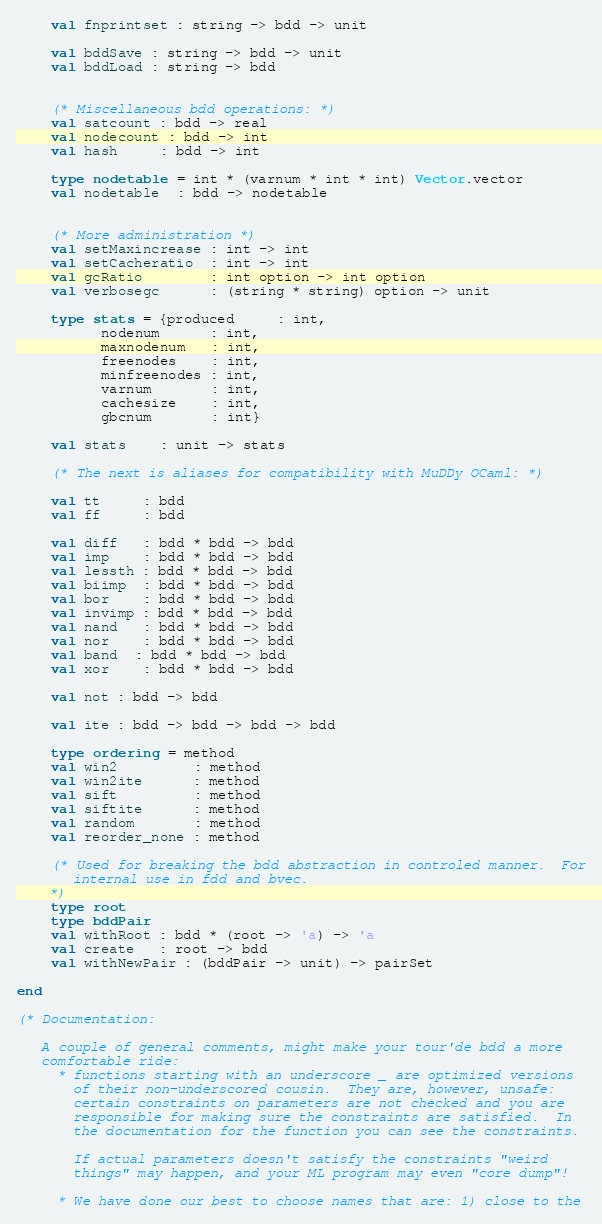Convert code to text. <code><loc_0><loc_0><loc_500><loc_500><_SML_>    val fnprintset : string -> bdd -> unit

    val bddSave : string -> bdd -> unit
    val bddLoad : string -> bdd

 
    (* Miscellaneous bdd operations: *)
    val satcount : bdd -> real
    val nodecount : bdd -> int
    val hash     : bdd -> int
    
    type nodetable = int * (varnum * int * int) Vector.vector
    val nodetable  : bdd -> nodetable 


    (* More administration *)
    val setMaxincrease : int -> int
    val setCacheratio  : int -> int
    val gcRatio        : int option -> int option
    val verbosegc      : (string * string) option -> unit

    type stats = {produced     : int,
		  nodenum      : int,
		  maxnodenum   : int,
		  freenodes    : int,
		  minfreenodes : int,
		  varnum       : int,
		  cachesize    : int,
		  gbcnum       : int}

    val stats    : unit -> stats

    (* The next is aliases for compatibility with MuDDy OCaml: *)

    val tt     : bdd
    val ff     : bdd

    val diff   : bdd * bdd -> bdd
    val imp    : bdd * bdd -> bdd
    val lessth : bdd * bdd -> bdd
    val biimp  : bdd * bdd -> bdd
    val bor    : bdd * bdd -> bdd
    val invimp : bdd * bdd -> bdd
    val nand   : bdd * bdd -> bdd
    val nor    : bdd * bdd -> bdd
    val band  : bdd * bdd -> bdd
    val xor    : bdd * bdd -> bdd

    val not : bdd -> bdd

    val ite : bdd -> bdd -> bdd -> bdd

    type ordering = method
    val win2         : method
    val win2ite      : method
    val sift         : method
    val siftite      : method
    val random       : method
    val reorder_none : method

    (* Used for breaking the bdd abstraction in controled manner.  For
       internal use in fdd and bvec.  
    *)
    type root
    type bddPair
    val withRoot : bdd * (root -> 'a) -> 'a
    val create   : root -> bdd
    val withNewPair : (bddPair -> unit) -> pairSet

end

(* Documentation:

   A couple of general comments, might make your tour'de bdd a more
   comfortable ride:
     * functions starting with an underscore _ are optimized versions
       of their non-underscored cousin.  They are, however, unsafe:
       certain constraints on parameters are not checked and you are
       responsible for making sure the constraints are satisfied.  In
       the documentation for the function you can see the constraints.

       If actual parameters doesn't satisfy the constraints "weird
       things" may happen, and your ML program may even "core dump"!

     * We have done our best to choose names that are: 1) close to the</code> 